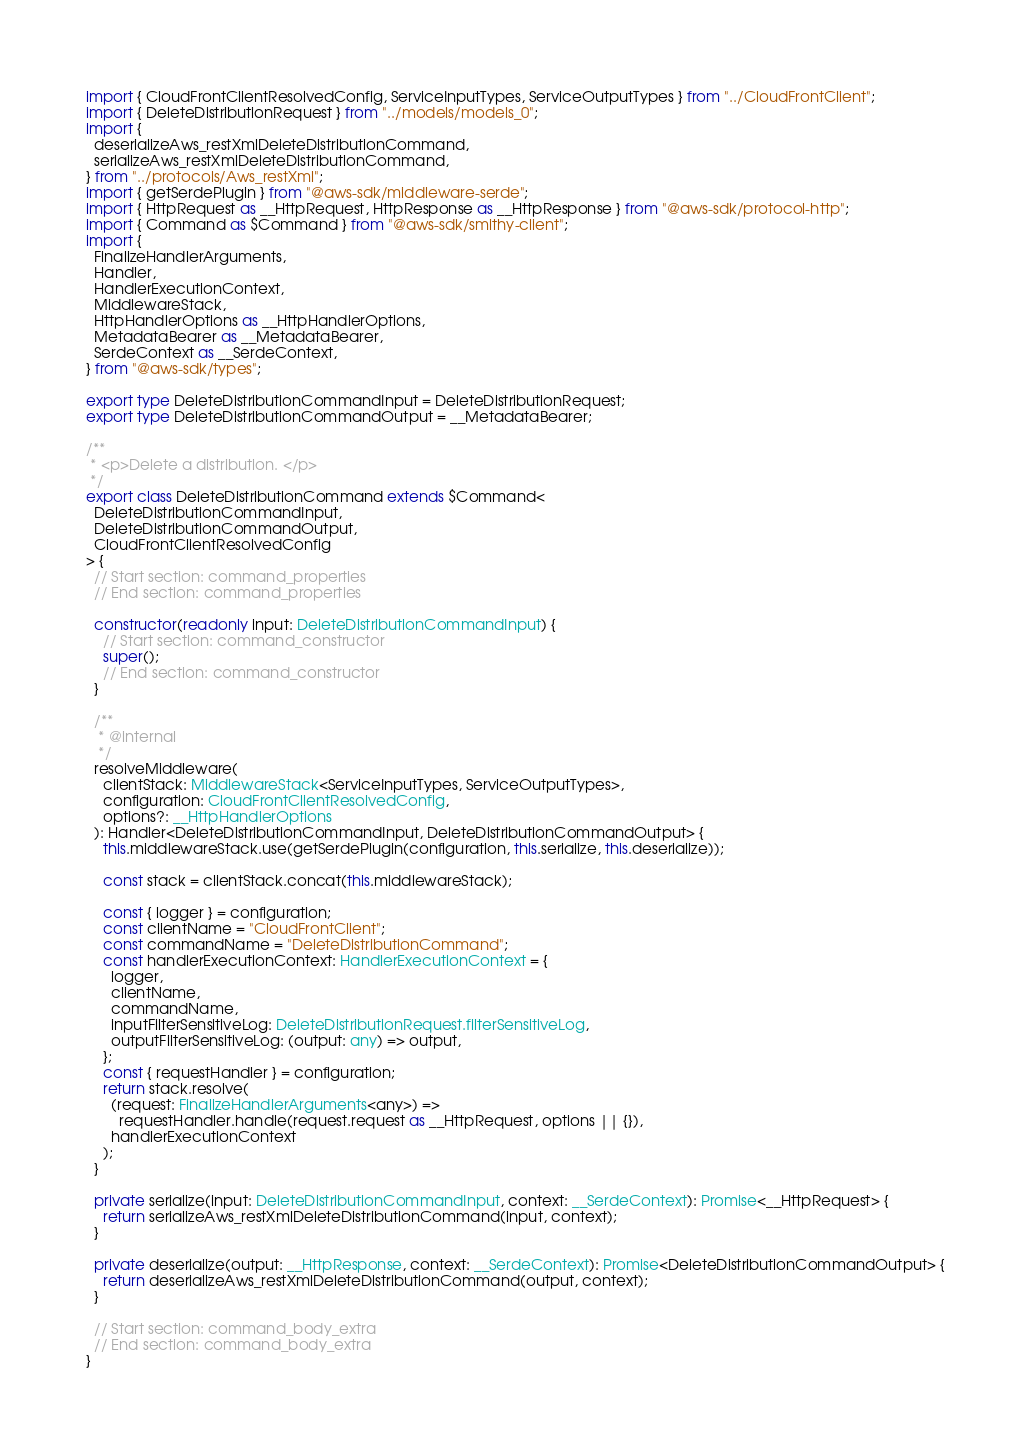Convert code to text. <code><loc_0><loc_0><loc_500><loc_500><_TypeScript_>import { CloudFrontClientResolvedConfig, ServiceInputTypes, ServiceOutputTypes } from "../CloudFrontClient";
import { DeleteDistributionRequest } from "../models/models_0";
import {
  deserializeAws_restXmlDeleteDistributionCommand,
  serializeAws_restXmlDeleteDistributionCommand,
} from "../protocols/Aws_restXml";
import { getSerdePlugin } from "@aws-sdk/middleware-serde";
import { HttpRequest as __HttpRequest, HttpResponse as __HttpResponse } from "@aws-sdk/protocol-http";
import { Command as $Command } from "@aws-sdk/smithy-client";
import {
  FinalizeHandlerArguments,
  Handler,
  HandlerExecutionContext,
  MiddlewareStack,
  HttpHandlerOptions as __HttpHandlerOptions,
  MetadataBearer as __MetadataBearer,
  SerdeContext as __SerdeContext,
} from "@aws-sdk/types";

export type DeleteDistributionCommandInput = DeleteDistributionRequest;
export type DeleteDistributionCommandOutput = __MetadataBearer;

/**
 * <p>Delete a distribution. </p>
 */
export class DeleteDistributionCommand extends $Command<
  DeleteDistributionCommandInput,
  DeleteDistributionCommandOutput,
  CloudFrontClientResolvedConfig
> {
  // Start section: command_properties
  // End section: command_properties

  constructor(readonly input: DeleteDistributionCommandInput) {
    // Start section: command_constructor
    super();
    // End section: command_constructor
  }

  /**
   * @internal
   */
  resolveMiddleware(
    clientStack: MiddlewareStack<ServiceInputTypes, ServiceOutputTypes>,
    configuration: CloudFrontClientResolvedConfig,
    options?: __HttpHandlerOptions
  ): Handler<DeleteDistributionCommandInput, DeleteDistributionCommandOutput> {
    this.middlewareStack.use(getSerdePlugin(configuration, this.serialize, this.deserialize));

    const stack = clientStack.concat(this.middlewareStack);

    const { logger } = configuration;
    const clientName = "CloudFrontClient";
    const commandName = "DeleteDistributionCommand";
    const handlerExecutionContext: HandlerExecutionContext = {
      logger,
      clientName,
      commandName,
      inputFilterSensitiveLog: DeleteDistributionRequest.filterSensitiveLog,
      outputFilterSensitiveLog: (output: any) => output,
    };
    const { requestHandler } = configuration;
    return stack.resolve(
      (request: FinalizeHandlerArguments<any>) =>
        requestHandler.handle(request.request as __HttpRequest, options || {}),
      handlerExecutionContext
    );
  }

  private serialize(input: DeleteDistributionCommandInput, context: __SerdeContext): Promise<__HttpRequest> {
    return serializeAws_restXmlDeleteDistributionCommand(input, context);
  }

  private deserialize(output: __HttpResponse, context: __SerdeContext): Promise<DeleteDistributionCommandOutput> {
    return deserializeAws_restXmlDeleteDistributionCommand(output, context);
  }

  // Start section: command_body_extra
  // End section: command_body_extra
}
</code> 